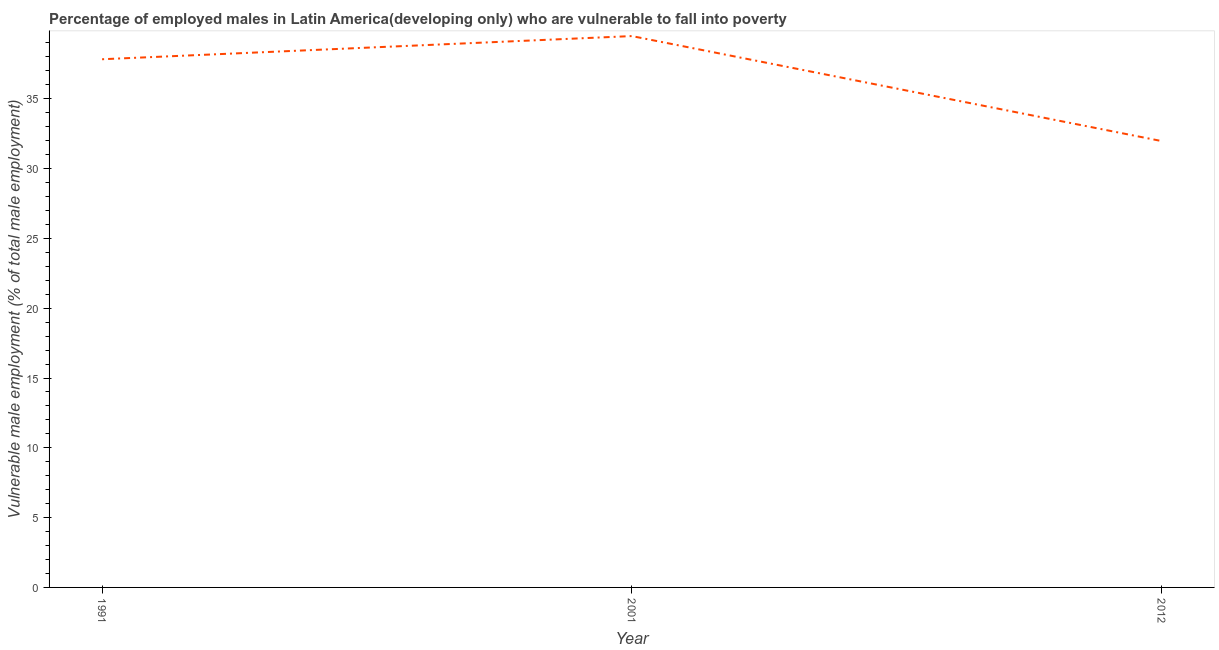What is the percentage of employed males who are vulnerable to fall into poverty in 2001?
Make the answer very short. 39.49. Across all years, what is the maximum percentage of employed males who are vulnerable to fall into poverty?
Give a very brief answer. 39.49. Across all years, what is the minimum percentage of employed males who are vulnerable to fall into poverty?
Make the answer very short. 31.97. What is the sum of the percentage of employed males who are vulnerable to fall into poverty?
Give a very brief answer. 109.3. What is the difference between the percentage of employed males who are vulnerable to fall into poverty in 1991 and 2001?
Provide a short and direct response. -1.66. What is the average percentage of employed males who are vulnerable to fall into poverty per year?
Provide a succinct answer. 36.43. What is the median percentage of employed males who are vulnerable to fall into poverty?
Provide a succinct answer. 37.83. In how many years, is the percentage of employed males who are vulnerable to fall into poverty greater than 36 %?
Your answer should be very brief. 2. What is the ratio of the percentage of employed males who are vulnerable to fall into poverty in 1991 to that in 2012?
Your answer should be very brief. 1.18. Is the percentage of employed males who are vulnerable to fall into poverty in 2001 less than that in 2012?
Provide a succinct answer. No. What is the difference between the highest and the second highest percentage of employed males who are vulnerable to fall into poverty?
Your answer should be very brief. 1.66. What is the difference between the highest and the lowest percentage of employed males who are vulnerable to fall into poverty?
Offer a very short reply. 7.52. What is the difference between two consecutive major ticks on the Y-axis?
Keep it short and to the point. 5. Are the values on the major ticks of Y-axis written in scientific E-notation?
Your answer should be very brief. No. Does the graph contain any zero values?
Keep it short and to the point. No. What is the title of the graph?
Offer a very short reply. Percentage of employed males in Latin America(developing only) who are vulnerable to fall into poverty. What is the label or title of the X-axis?
Keep it short and to the point. Year. What is the label or title of the Y-axis?
Offer a very short reply. Vulnerable male employment (% of total male employment). What is the Vulnerable male employment (% of total male employment) of 1991?
Provide a succinct answer. 37.83. What is the Vulnerable male employment (% of total male employment) of 2001?
Keep it short and to the point. 39.49. What is the Vulnerable male employment (% of total male employment) of 2012?
Ensure brevity in your answer.  31.97. What is the difference between the Vulnerable male employment (% of total male employment) in 1991 and 2001?
Your answer should be compact. -1.66. What is the difference between the Vulnerable male employment (% of total male employment) in 1991 and 2012?
Provide a succinct answer. 5.86. What is the difference between the Vulnerable male employment (% of total male employment) in 2001 and 2012?
Ensure brevity in your answer.  7.52. What is the ratio of the Vulnerable male employment (% of total male employment) in 1991 to that in 2001?
Provide a succinct answer. 0.96. What is the ratio of the Vulnerable male employment (% of total male employment) in 1991 to that in 2012?
Your answer should be compact. 1.18. What is the ratio of the Vulnerable male employment (% of total male employment) in 2001 to that in 2012?
Ensure brevity in your answer.  1.24. 